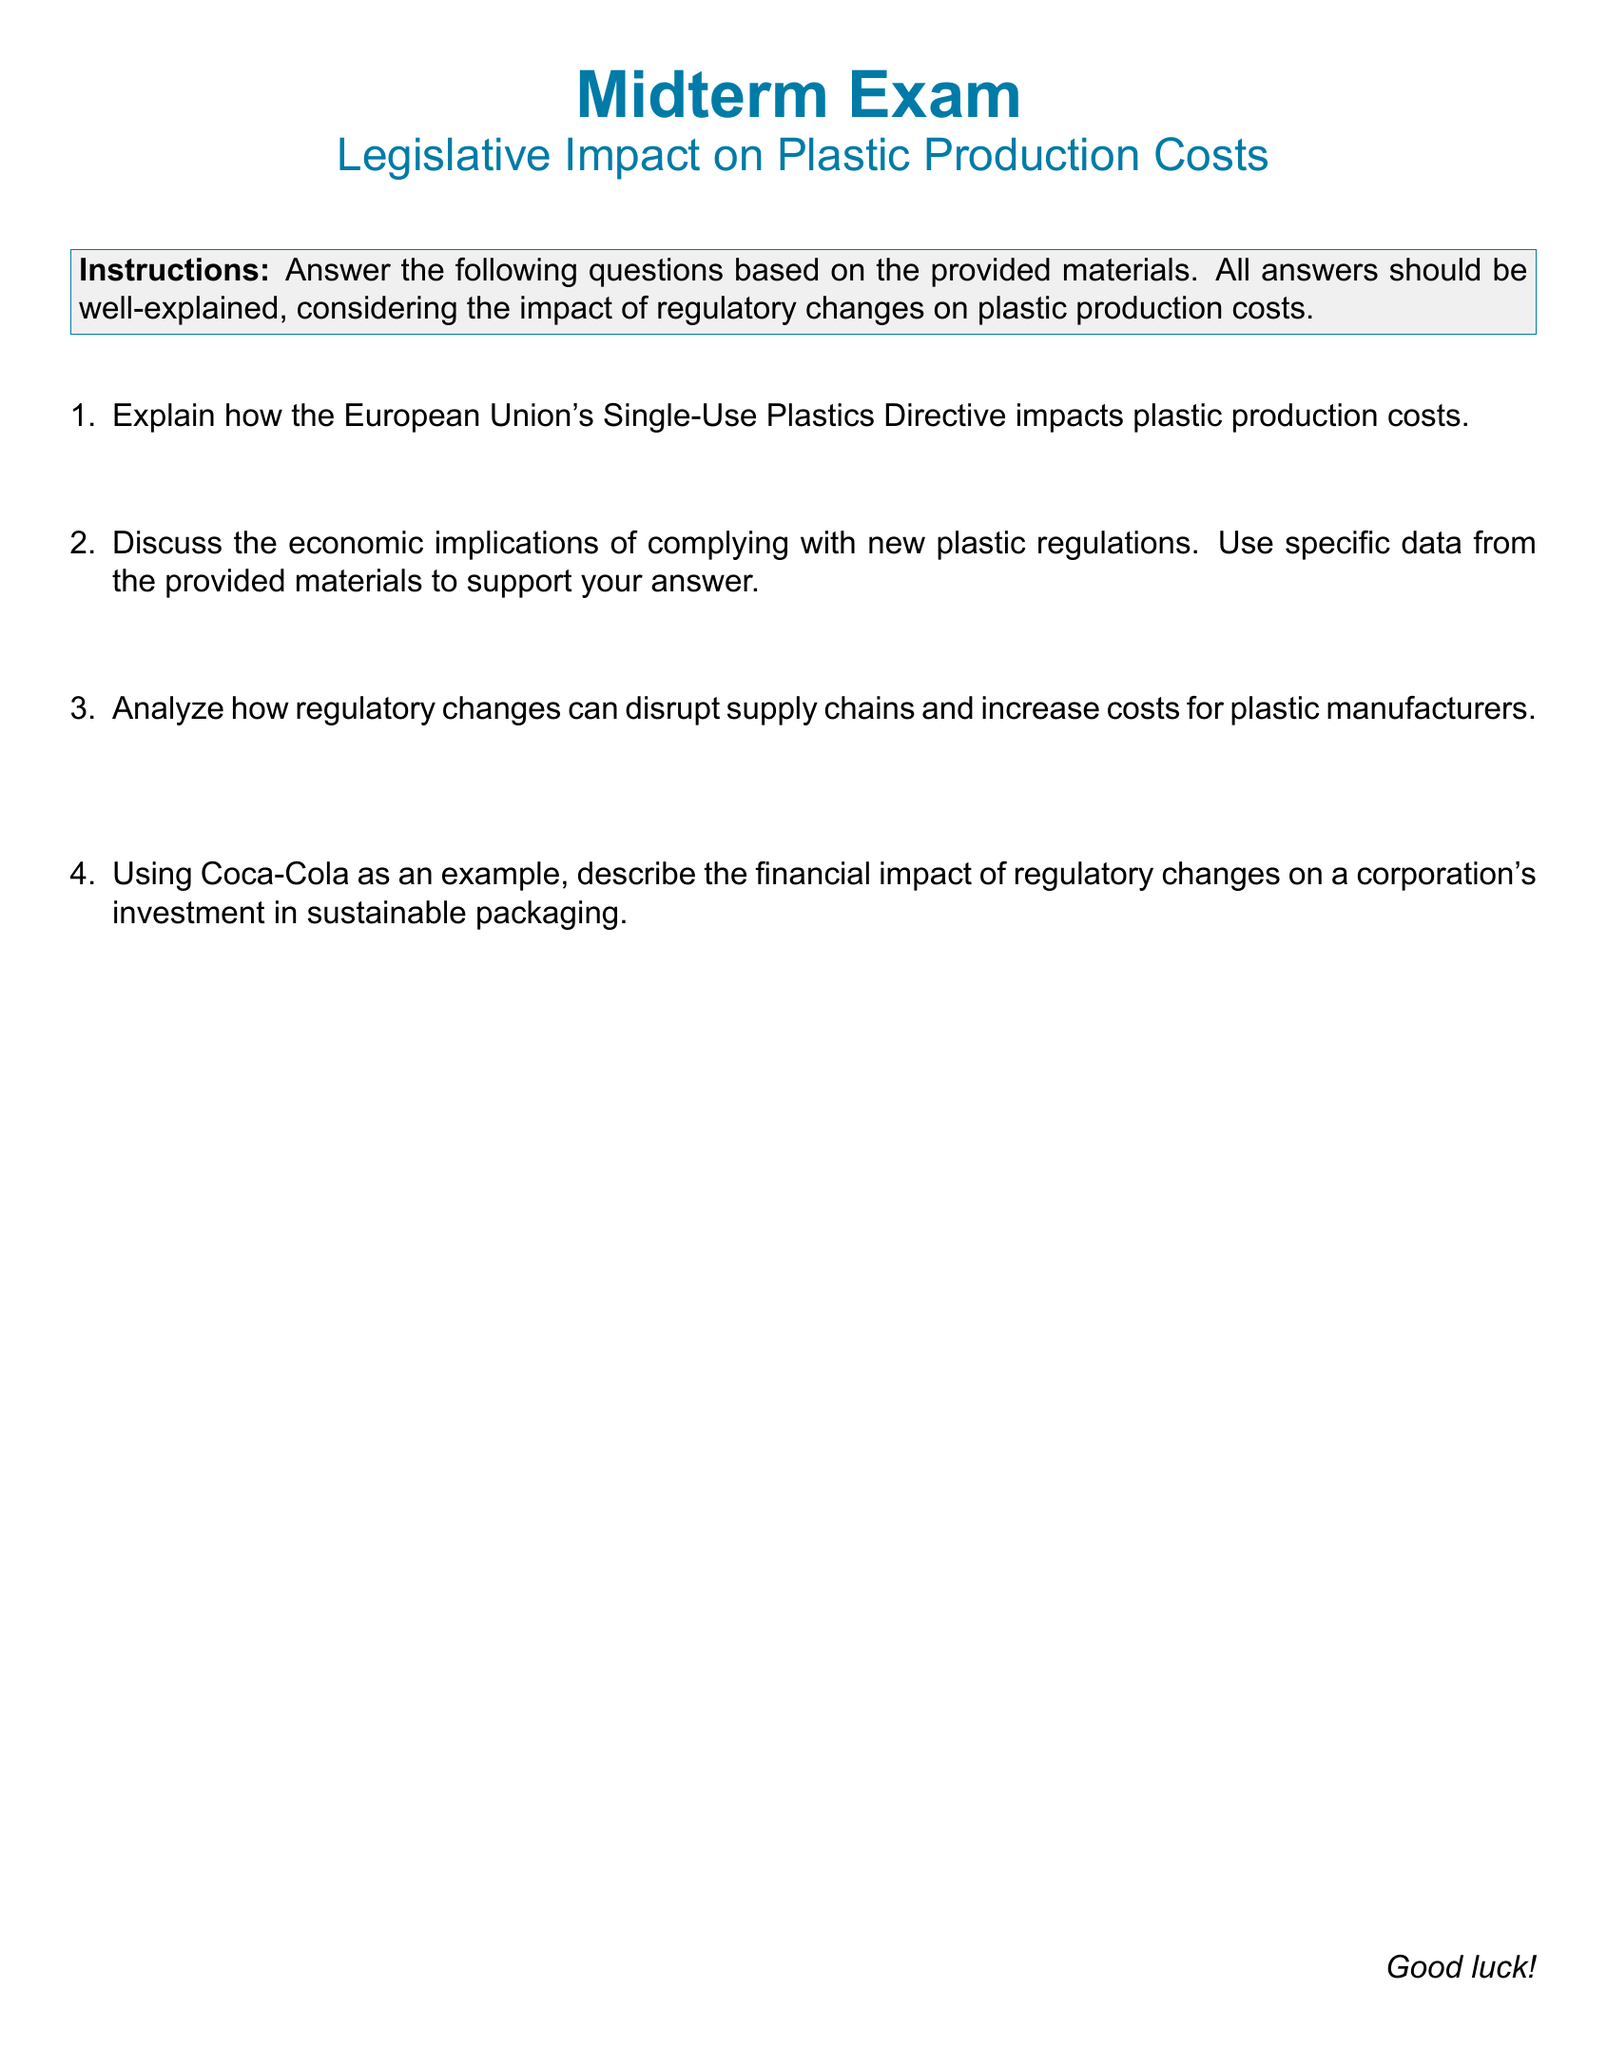What is the subject of the midterm exam? The subject is about the impact of legislative changes on plastic production costs specifically focusing on regulatory impacts.
Answer: Legislative Impact on Plastic Production Costs What is the directive mentioned that affects plastic production? The document refers to the European Union's directive that targets single-use plastics, which imposes restrictions affecting production costs.
Answer: Single-Use Plastics Directive How many questions are included in the exam? The document outlines a total of four questions for students to answer concerning legislative impacts on plastic manufacturing.
Answer: Four What is the color theme used in the document? The document employs a specific color theme characterized by shades of blue for headings and text.
Answer: Plastic blue What specific company's investment is analyzed in terms of regulatory impact? The exam question specifically uses Coca-Cola as a case study for understanding financial implications regarding sustainable packaging.
Answer: Coca-Cola How should the answers be presented according to the instructions? The instructions state that all answers should be well-explained, particularly concerning the impact of regulatory changes.
Answer: Well-explained Which section format is specified for the document's headings? The document uses a specific format for headings, described as being in a larger font size and bold with a defined color.
Answer: Normalfont Large bfseries What is the primary focus of the first question in the exam? The first question requests an explanation regarding the impact of a specific directive, hinting at how it influences production costs.
Answer: Impact of the Single-Use Plastics Directive How should the responses in the exam be structured? Students are instructed to offer thorough explanations, taking into consideration the regulatory impact on plastic production costs.
Answer: Thorough explanations 